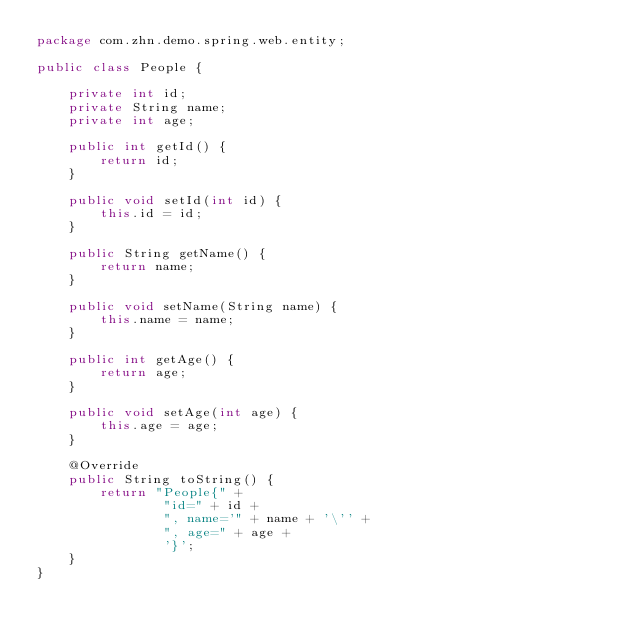Convert code to text. <code><loc_0><loc_0><loc_500><loc_500><_Java_>package com.zhn.demo.spring.web.entity;

public class People {

    private int id;
    private String name;
    private int age;

    public int getId() {
        return id;
    }

    public void setId(int id) {
        this.id = id;
    }

    public String getName() {
        return name;
    }

    public void setName(String name) {
        this.name = name;
    }

    public int getAge() {
        return age;
    }

    public void setAge(int age) {
        this.age = age;
    }

    @Override
    public String toString() {
        return "People{" +
                "id=" + id +
                ", name='" + name + '\'' +
                ", age=" + age +
                '}';
    }
}
</code> 